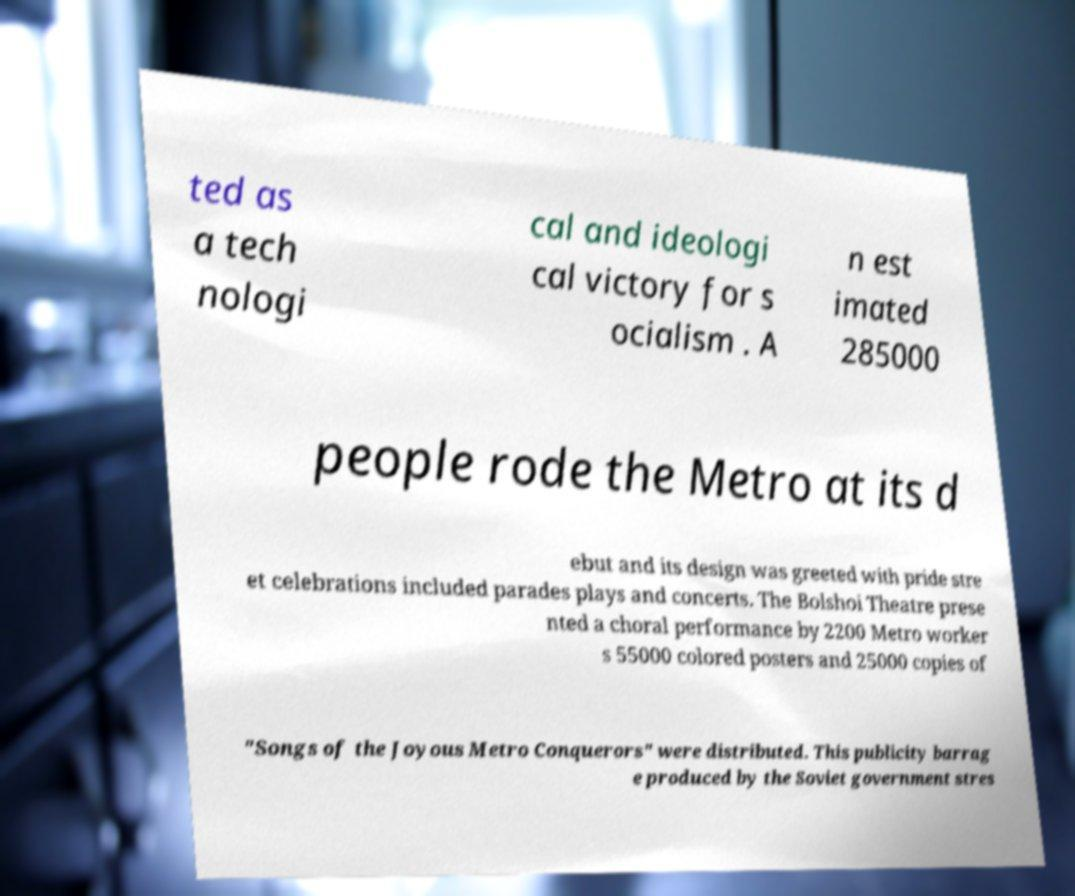There's text embedded in this image that I need extracted. Can you transcribe it verbatim? ted as a tech nologi cal and ideologi cal victory for s ocialism . A n est imated 285000 people rode the Metro at its d ebut and its design was greeted with pride stre et celebrations included parades plays and concerts. The Bolshoi Theatre prese nted a choral performance by 2200 Metro worker s 55000 colored posters and 25000 copies of "Songs of the Joyous Metro Conquerors" were distributed. This publicity barrag e produced by the Soviet government stres 